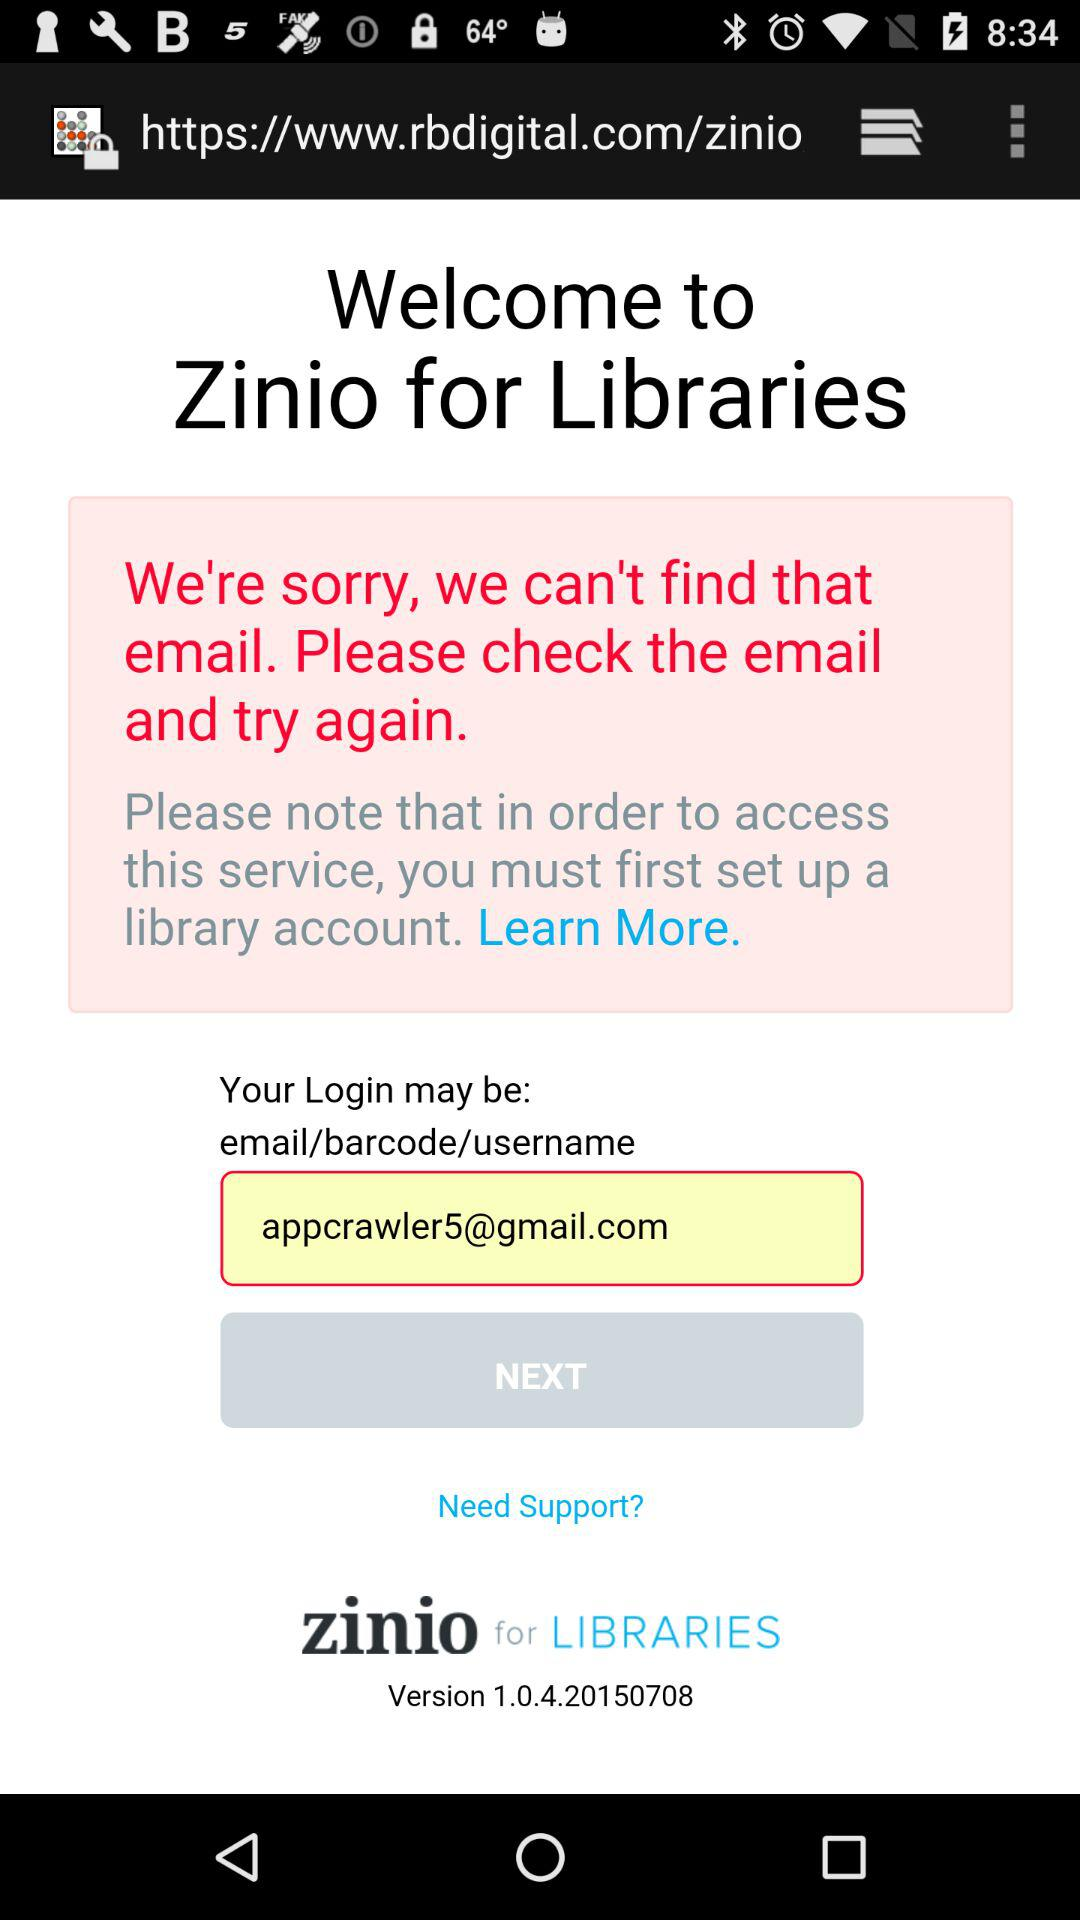What is the email address? The email address is appcrawler5@gmail.com. 